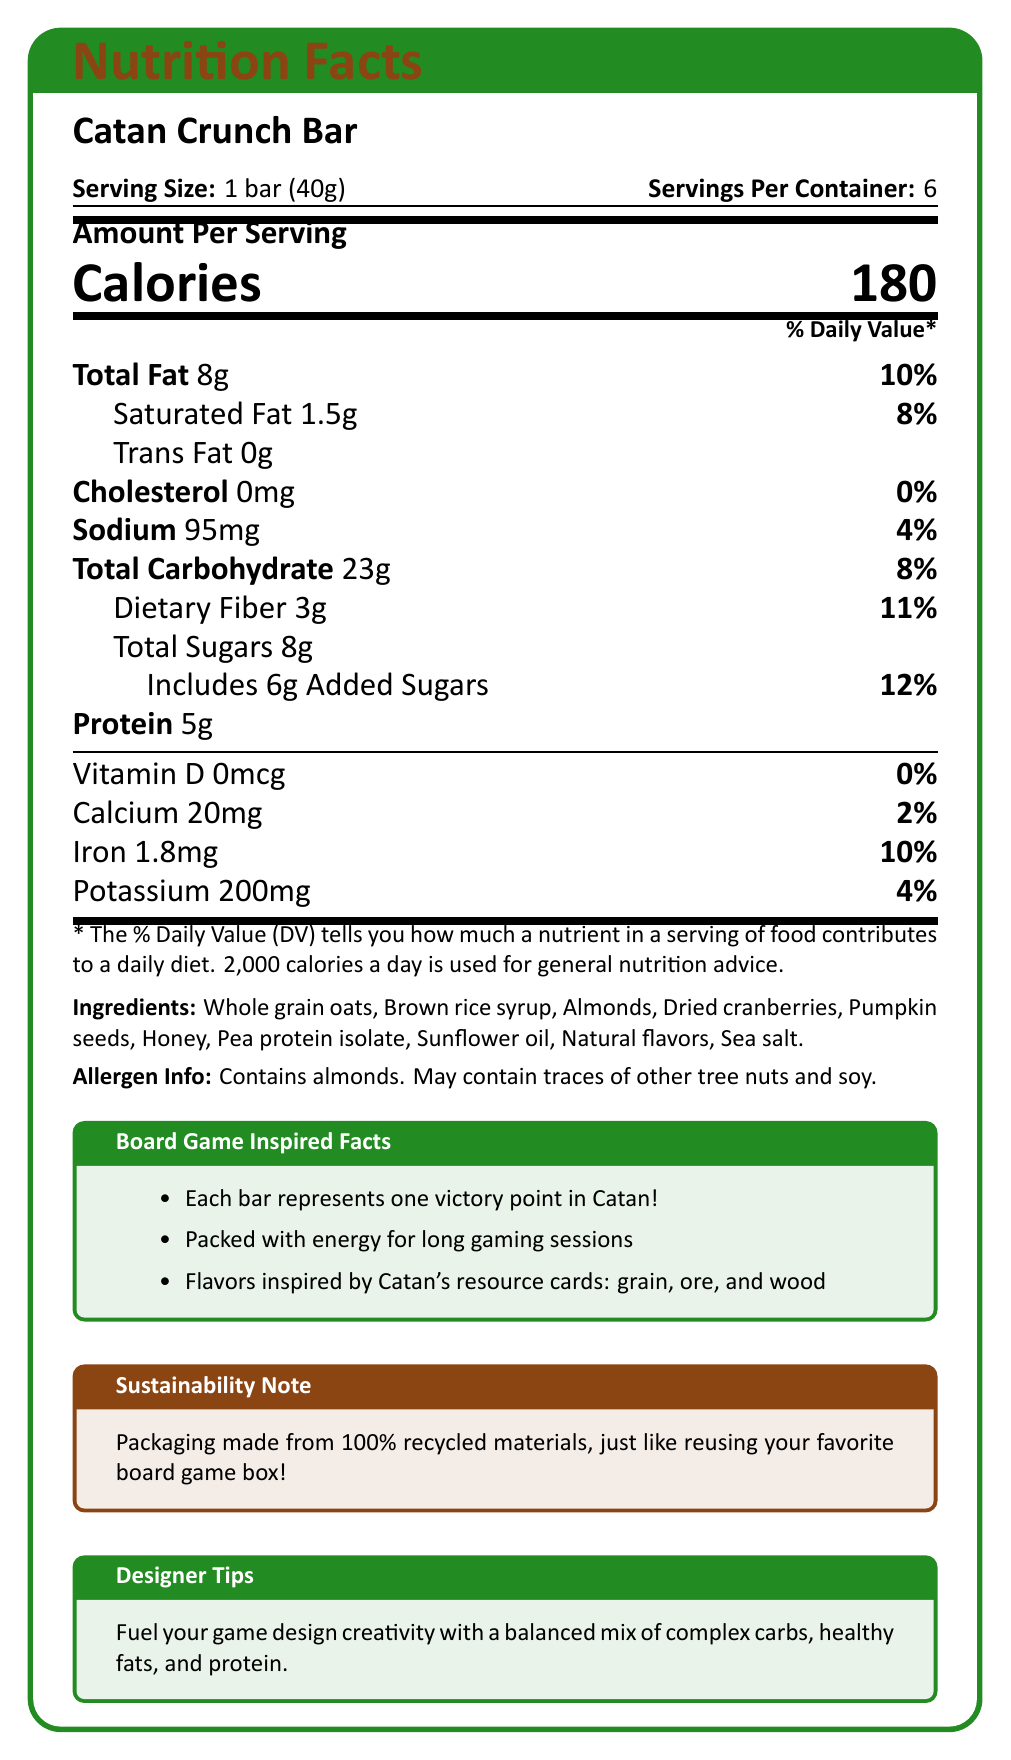what is the serving size of the Catan Crunch Bar? The document states that the serving size is 1 bar (40g).
Answer: 1 bar (40g) how many servings are there in a container of Catan Crunch Bar? The document specifies there are 6 servings per container.
Answer: 6 how many calories are in each serving of the Catan Crunch Bar? The document lists the amount of calories per serving as 180.
Answer: 180 how much protein does each serving of the Catan Crunch Bar contain? The document states that each serving contains 5g of protein.
Answer: 5g what is the percentage daily value of iron in one serving of the Catan Crunch Bar? The document indicates that the percentage daily value of iron per serving is 10%.
Answer: 10% how much total dietary fiber is in each serving of the Catan Crunch Bar? The document shows that each serving has 3g of dietary fiber.
Answer: 3g which of the following ingredients is NOT present in the Catan Crunch Bar? A. Almonds B. Dried cranberries C. Peanuts D. Pumpkin seeds Peanuts are not listed in the ingredients; the listed ingredients include almonds, dried cranberries, and pumpkin seeds.
Answer: C. Peanuts what is the daily value percentage of sodium in one serving? A. 2% B. 4% C. 10% D. 12% The sodium daily value percentage in one serving of the Catan Crunch Bar is 4%.
Answer: B. 4% does the Catan Crunch Bar contain any cholesterol? The document states that the Catan Crunch Bar contains 0mg of cholesterol, which is 0% of the daily value.
Answer: No summarize the main purpose and content of the document. The document provides detailed nutritional information about the Catan Crunch Bar, ingredients, allergen warnings, and highlights the bar's inspiration from the Catan board game, along with sustainability packaging and a note for fueling creative game design.
Answer: The document presents the nutrition facts and key features of the Catan Crunch Bar, a healthy snack inspired by the Catan board game. It includes serving size, nutritional values, ingredients, allergen information, and special notes on sustainability and board game inspiration. what are the sources of protein in the Catan Crunch Bar? The document lists Almonds and Pea protein isolate among the ingredients, both of which are sources of protein.
Answer: Almonds, Pea protein isolate does the Catan Crunch Bar's packaging contribute to environmental sustainability? The document mentions that the packaging is made from 100% recycled materials.
Answer: Yes what should you do if you have a tree nut allergy? The document states the bar contains almonds and may contain traces of other tree nuts, but it does not provide complete guidance on what to do if you have a tree nut allergy.
Answer: Not enough information how many grams of added sugars does each Catan Crunch Bar contain? The document specifies that each serving includes 6g of added sugars.
Answer: 6g how is the flavor of the Catan Crunch Bar inspired by the Catan board game? The document mentions that the flavors are inspired by Catan's resource cards: grain, ore, and wood.
Answer: It's inspired by Catan's resource cards: grain, ore, and wood 